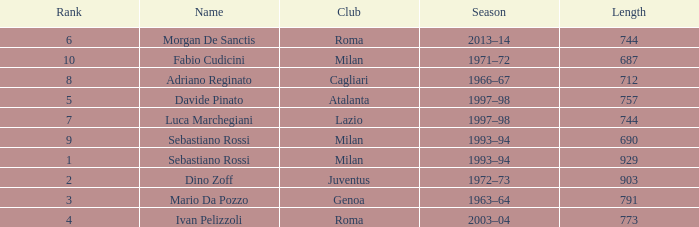What name is associated with a longer length than 903? Sebastiano Rossi. 